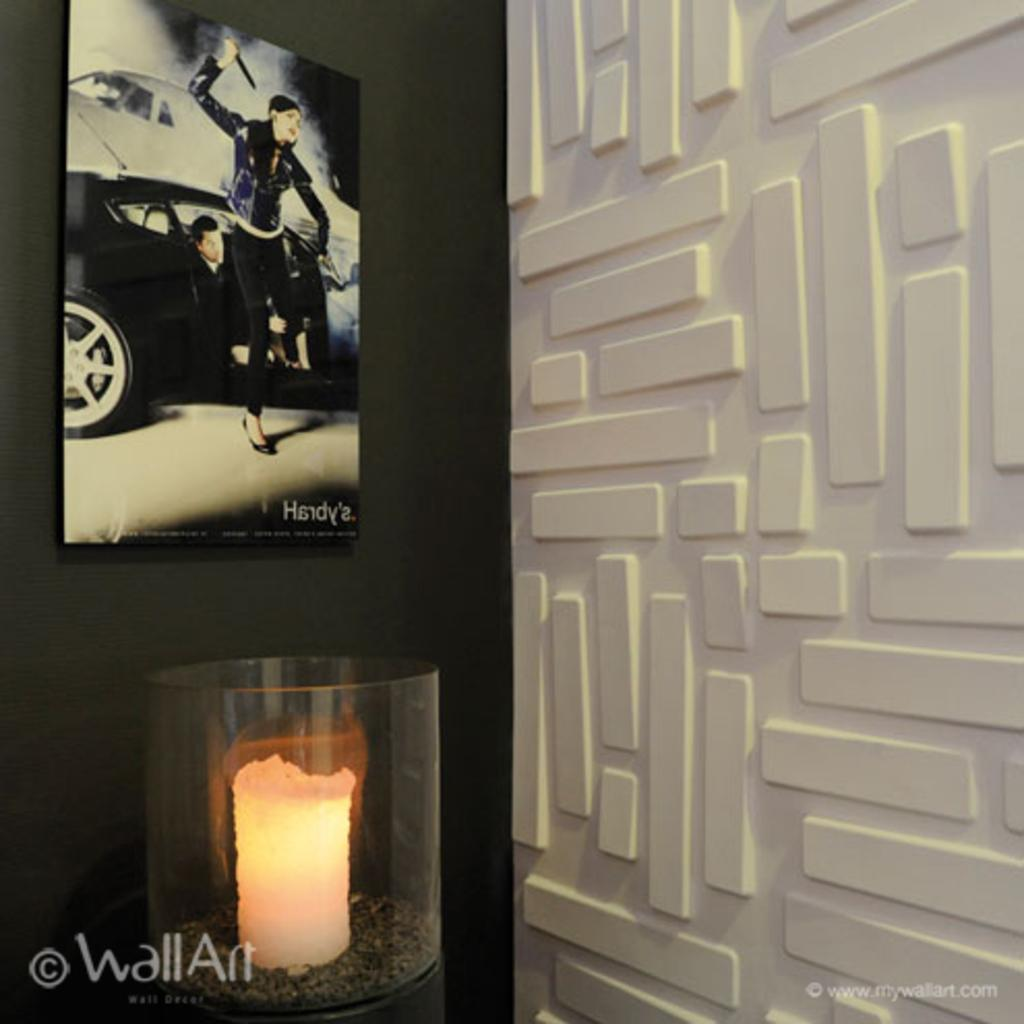What is the main subject in the image? There is an object in the image. Where is the object located? The object is attached to the wall. What else is attached to the wall in the image? There is a frame attached to the wall. Can you describe the design on the wall? There is a design on the wall. What additional detail can be observed in the image? There are watermarks in the image. How much does the jar weigh in the image? There is no jar present in the image, so it is not possible to determine its weight. 